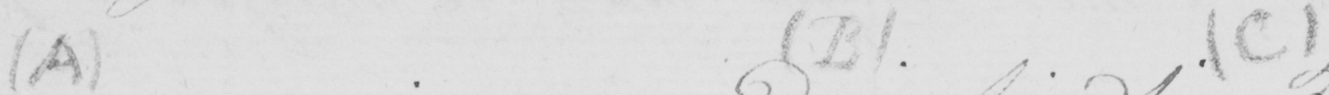Please provide the text content of this handwritten line. ( A )   ( B )   ( C ) 